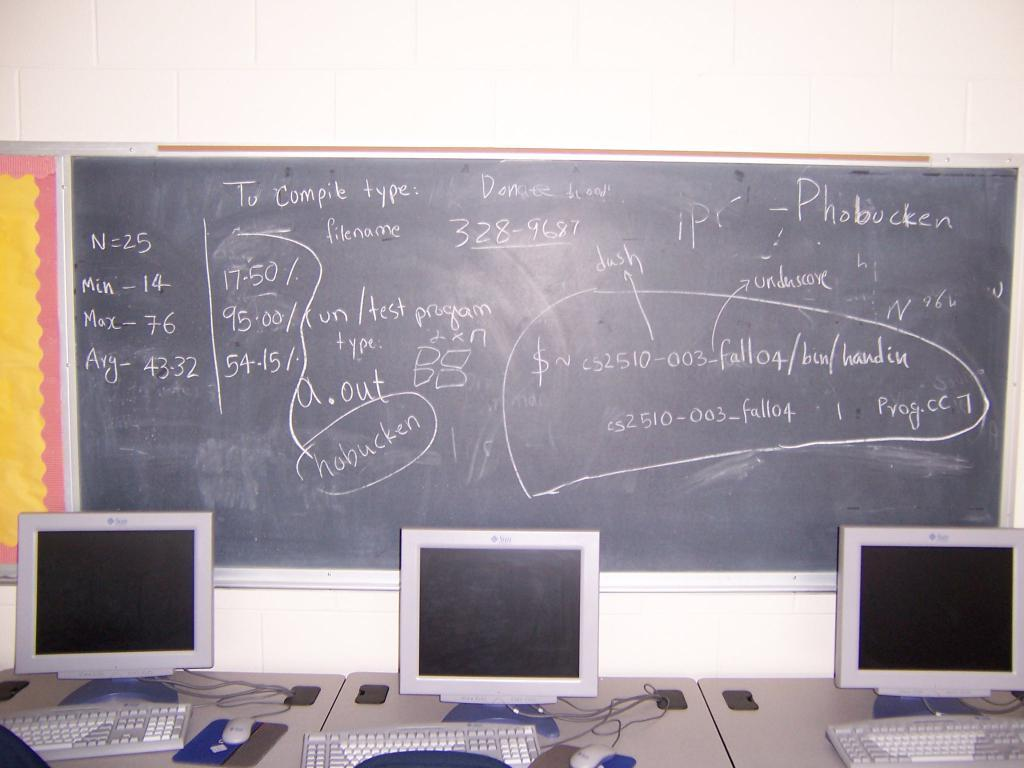<image>
Summarize the visual content of the image. A chalk board displays instructions to compile a computer program. 